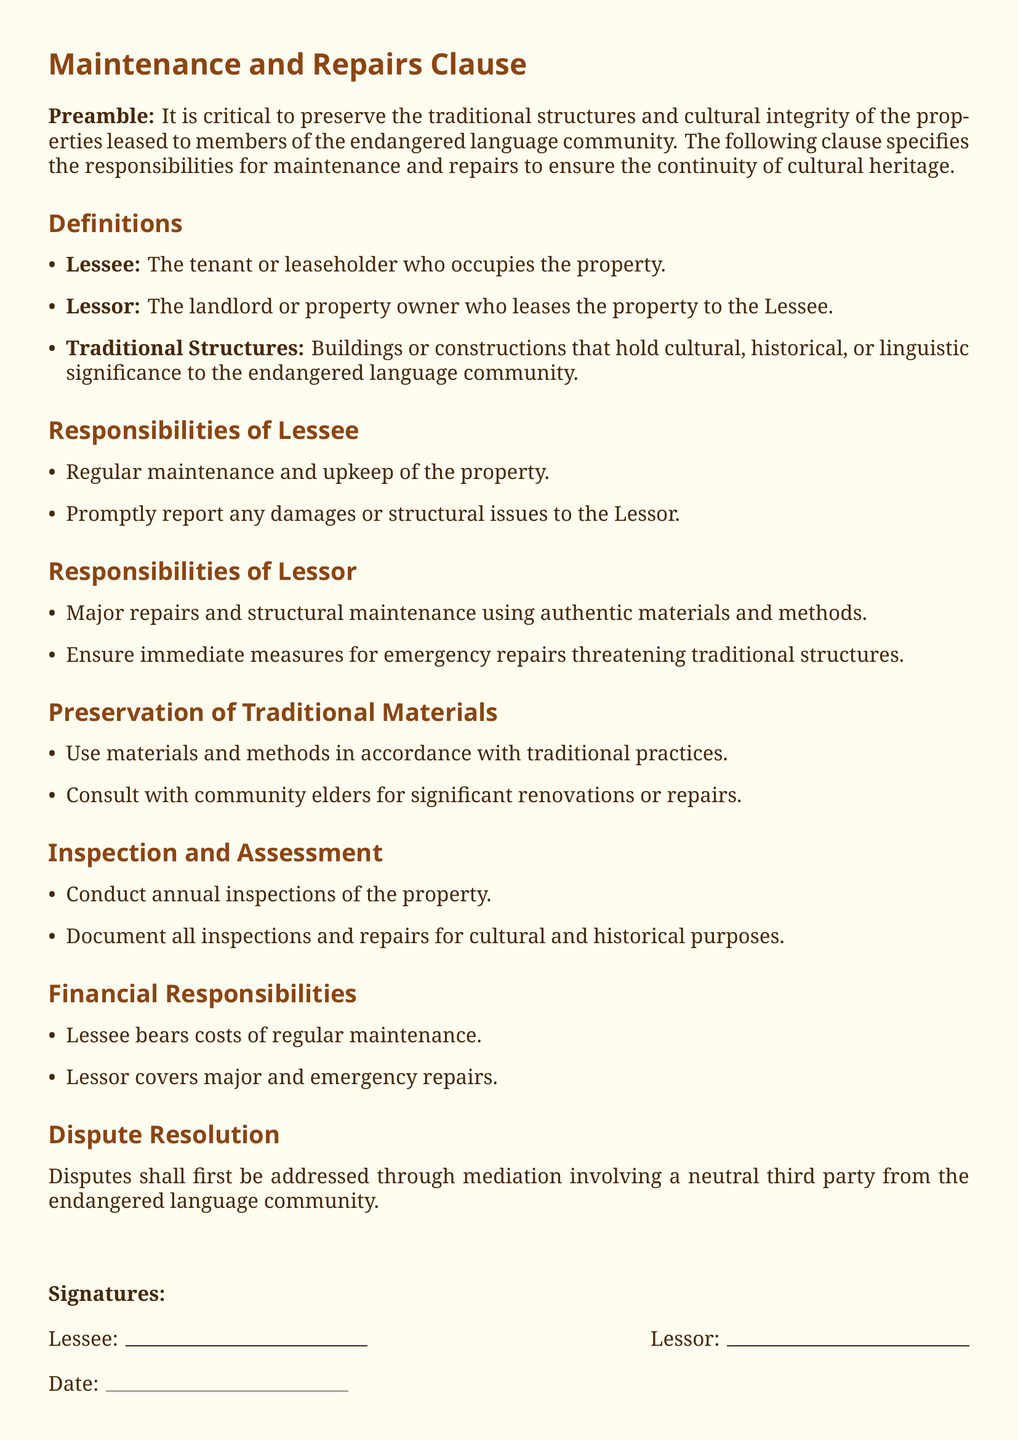What is the responsibility of the Lessee regarding maintenance? The Lessee is responsible for regular maintenance and upkeep of the property.
Answer: Regular maintenance and upkeep What are the major repairs covered by the Lessor? The Lessor is responsible for major repairs and structural maintenance using authentic materials and methods.
Answer: Major repairs and structural maintenance What must be consulted for significant renovations? The document states that community elders must be consulted for significant renovations or repairs.
Answer: Community elders How often are inspections of the property conducted? The property is inspected annually, as specified in the document.
Answer: Annually Who bears the costs of regular maintenance? The Lessee bears the costs of regular maintenance according to the financial responsibilities outlined.
Answer: Lessee What should be done in case of disputes? Disputes should be addressed through mediation involving a neutral third party from the endangered language community.
Answer: Mediation What type of structures does the document emphasize preserving? The document emphasizes preserving Traditional Structures that hold cultural, historical, or linguistic significance.
Answer: Traditional Structures What should the Lessor ensure during emergency repairs? The Lessor should ensure immediate measures for emergency repairs threatening traditional structures.
Answer: Immediate measures 